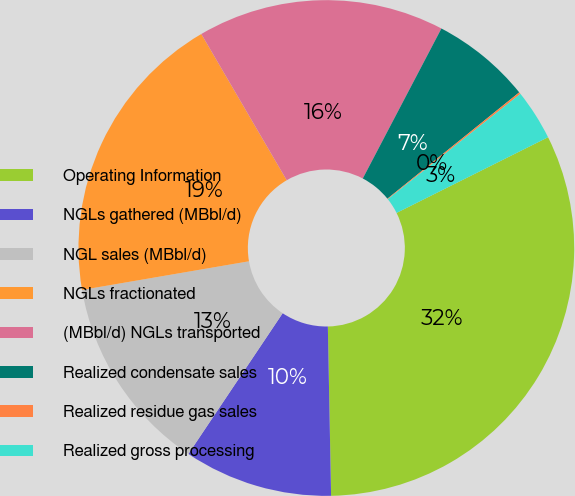<chart> <loc_0><loc_0><loc_500><loc_500><pie_chart><fcel>Operating Information<fcel>NGLs gathered (MBbl/d)<fcel>NGL sales (MBbl/d)<fcel>NGLs fractionated<fcel>(MBbl/d) NGLs transported<fcel>Realized condensate sales<fcel>Realized residue gas sales<fcel>Realized gross processing<nl><fcel>32.07%<fcel>9.7%<fcel>12.9%<fcel>19.29%<fcel>16.1%<fcel>6.51%<fcel>0.12%<fcel>3.31%<nl></chart> 